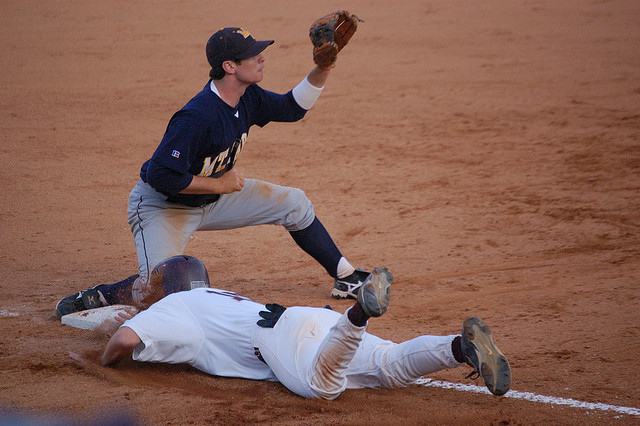<image>Is he safe? I am not sure if he is safe. Is he safe? I am not sure if he is safe. But it can be seen that he is safe. 